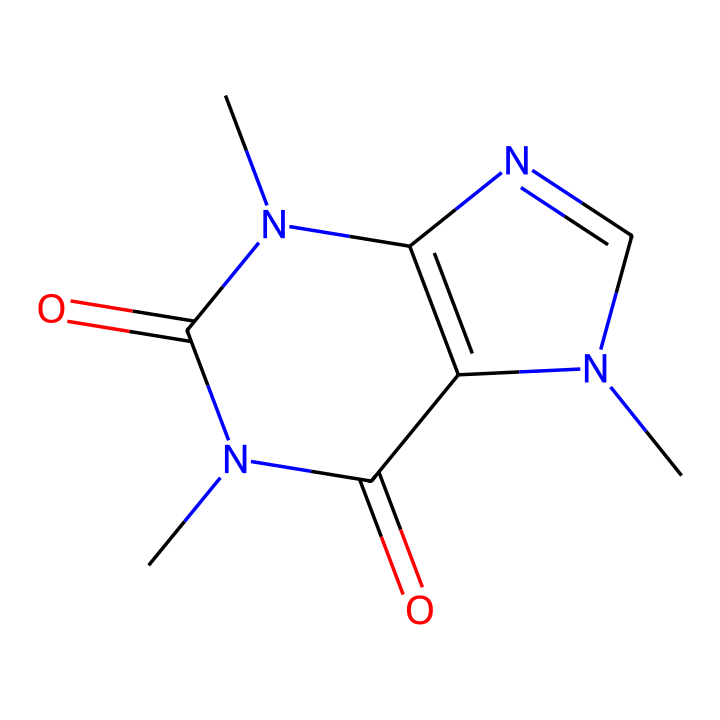How many nitrogen atoms are in this structure? By inspecting the SMILES notation, we can identify the nitrogen atoms represented by the letter "N". There are three instances of "N" in the structure.
Answer: three What is the molecular formula for caffeine? To derive the molecular formula, we need to count the number of each type of atom in the structure. The counts yield: 8 carbons (C), 10 hydrogens (H), 4 nitrogens (N), and 2 oxygens (O), leading to the formula C8H10N4O2.
Answer: C8H10N4O2 Which type of compound does caffeine belong to? Caffeine is classified as an alkaloid based on its nitrogen-containing structure and its physiological effects. Alkaloids are often derived from plants and have significant biological activity.
Answer: alkaloid How many rings are present in caffeine's structure? Looking at the chemical structure, caffeine contains two fused rings, often referred to as bicyclic. The interpretation of cyclic structures can be determined by the connections among the atoms in the SMILES.
Answer: two What functional groups are present in caffeine? Analyzing the structure, we can identify the functional groups, such as carbonyl groups (C=O) and amine groups (N-H) due to the presence of nitrogen. This implies the presence of amide functionalities as caffeine is a derivative of theobromine.
Answer: carbonyl and amine What is the main effect of caffeine on the human body? Caffeine primarily acts as a central nervous system stimulant and leads to increased alertness. This effect is due to its interactions with adenosine receptors in the brain.
Answer: stimulant 